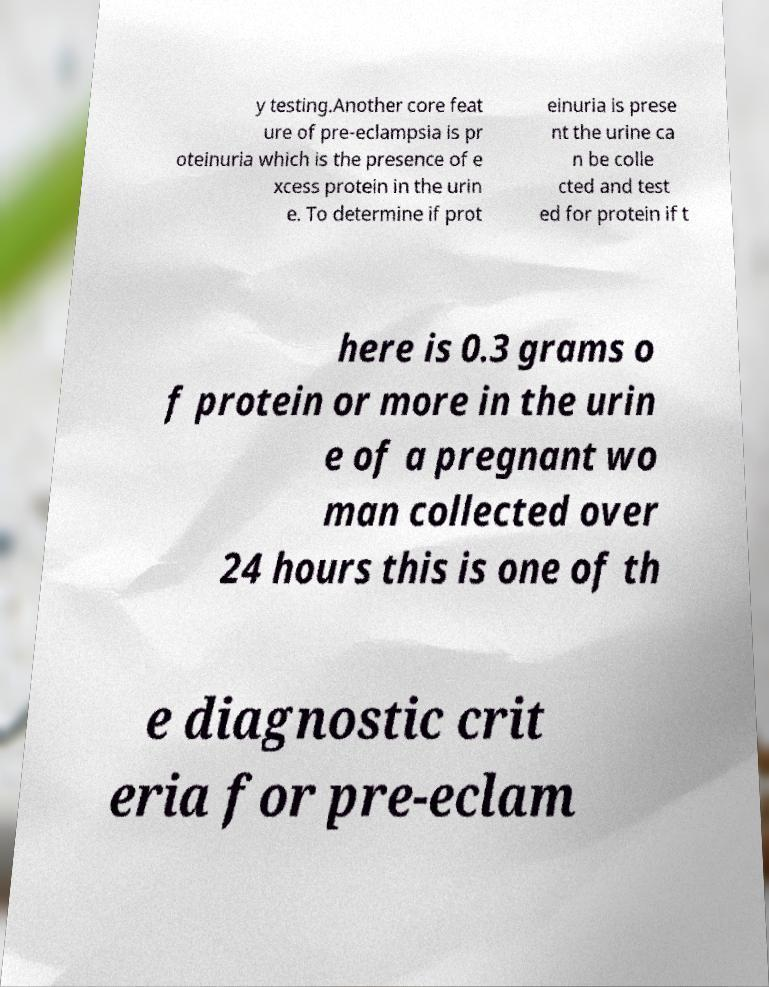There's text embedded in this image that I need extracted. Can you transcribe it verbatim? y testing.Another core feat ure of pre-eclampsia is pr oteinuria which is the presence of e xcess protein in the urin e. To determine if prot einuria is prese nt the urine ca n be colle cted and test ed for protein if t here is 0.3 grams o f protein or more in the urin e of a pregnant wo man collected over 24 hours this is one of th e diagnostic crit eria for pre-eclam 